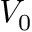Convert formula to latex. <formula><loc_0><loc_0><loc_500><loc_500>V _ { 0 }</formula> 